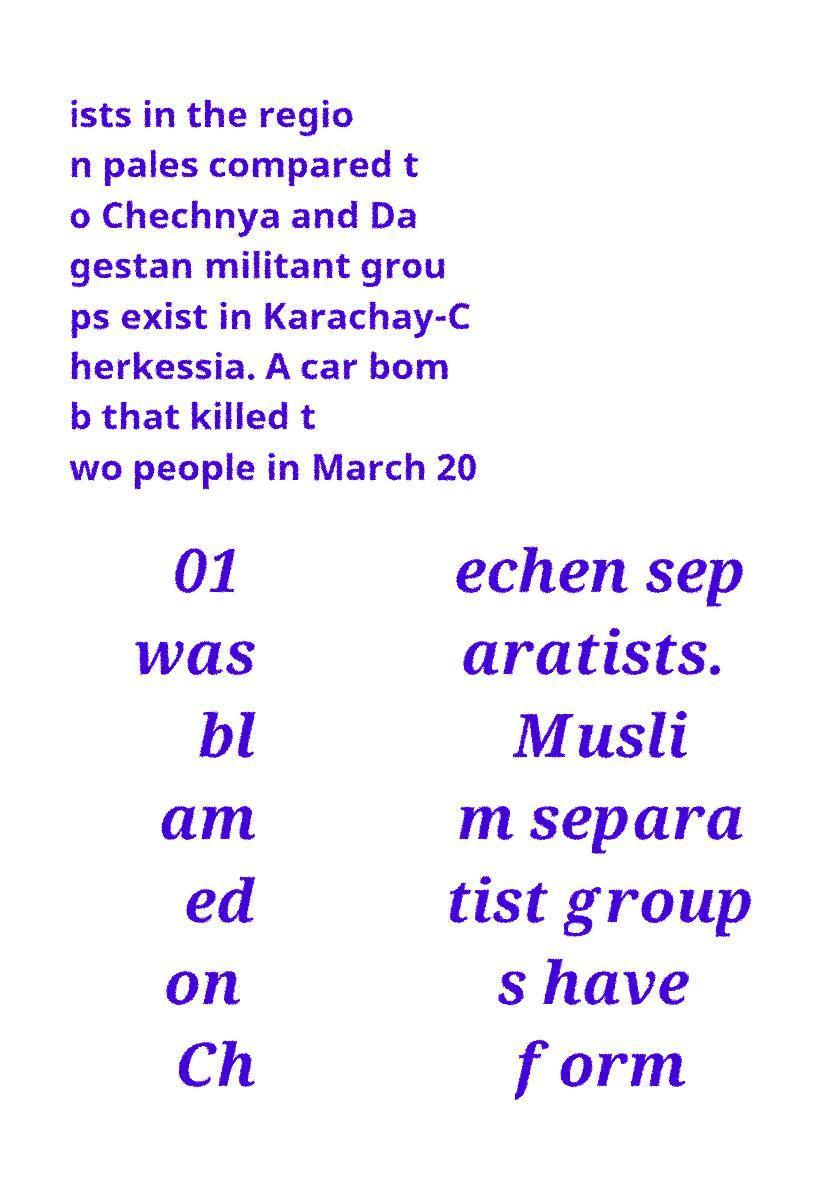Please identify and transcribe the text found in this image. ists in the regio n pales compared t o Chechnya and Da gestan militant grou ps exist in Karachay-C herkessia. A car bom b that killed t wo people in March 20 01 was bl am ed on Ch echen sep aratists. Musli m separa tist group s have form 